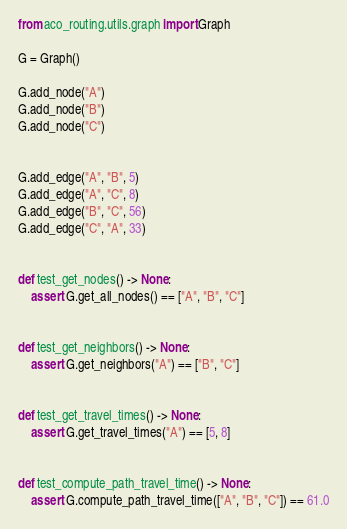<code> <loc_0><loc_0><loc_500><loc_500><_Python_>from aco_routing.utils.graph import Graph

G = Graph()

G.add_node("A")
G.add_node("B")
G.add_node("C")


G.add_edge("A", "B", 5)
G.add_edge("A", "C", 8)
G.add_edge("B", "C", 56)
G.add_edge("C", "A", 33)


def test_get_nodes() -> None:
    assert G.get_all_nodes() == ["A", "B", "C"]


def test_get_neighbors() -> None:
    assert G.get_neighbors("A") == ["B", "C"]


def test_get_travel_times() -> None:
    assert G.get_travel_times("A") == [5, 8]


def test_compute_path_travel_time() -> None:
    assert G.compute_path_travel_time(["A", "B", "C"]) == 61.0
</code> 